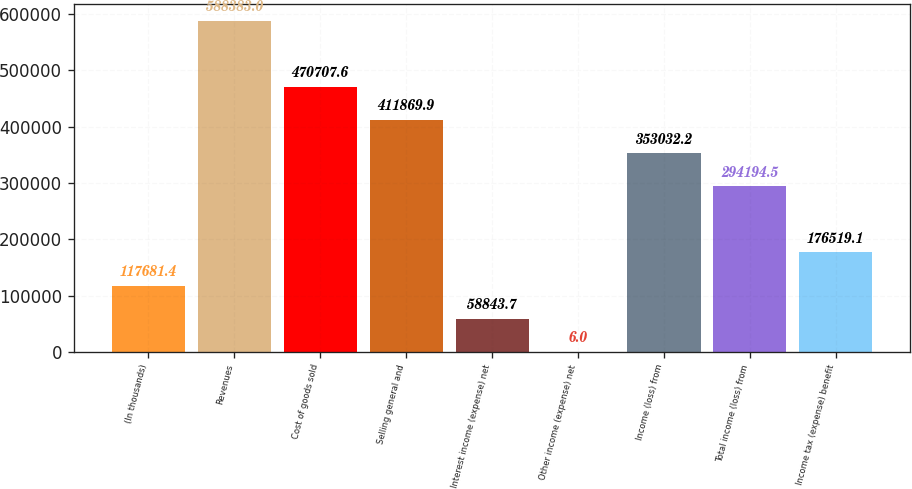Convert chart to OTSL. <chart><loc_0><loc_0><loc_500><loc_500><bar_chart><fcel>(In thousands)<fcel>Revenues<fcel>Cost of goods sold<fcel>Selling general and<fcel>Interest income (expense) net<fcel>Other income (expense) net<fcel>Income (loss) from<fcel>Total income (loss) from<fcel>Income tax (expense) benefit<nl><fcel>117681<fcel>588383<fcel>470708<fcel>411870<fcel>58843.7<fcel>6<fcel>353032<fcel>294194<fcel>176519<nl></chart> 